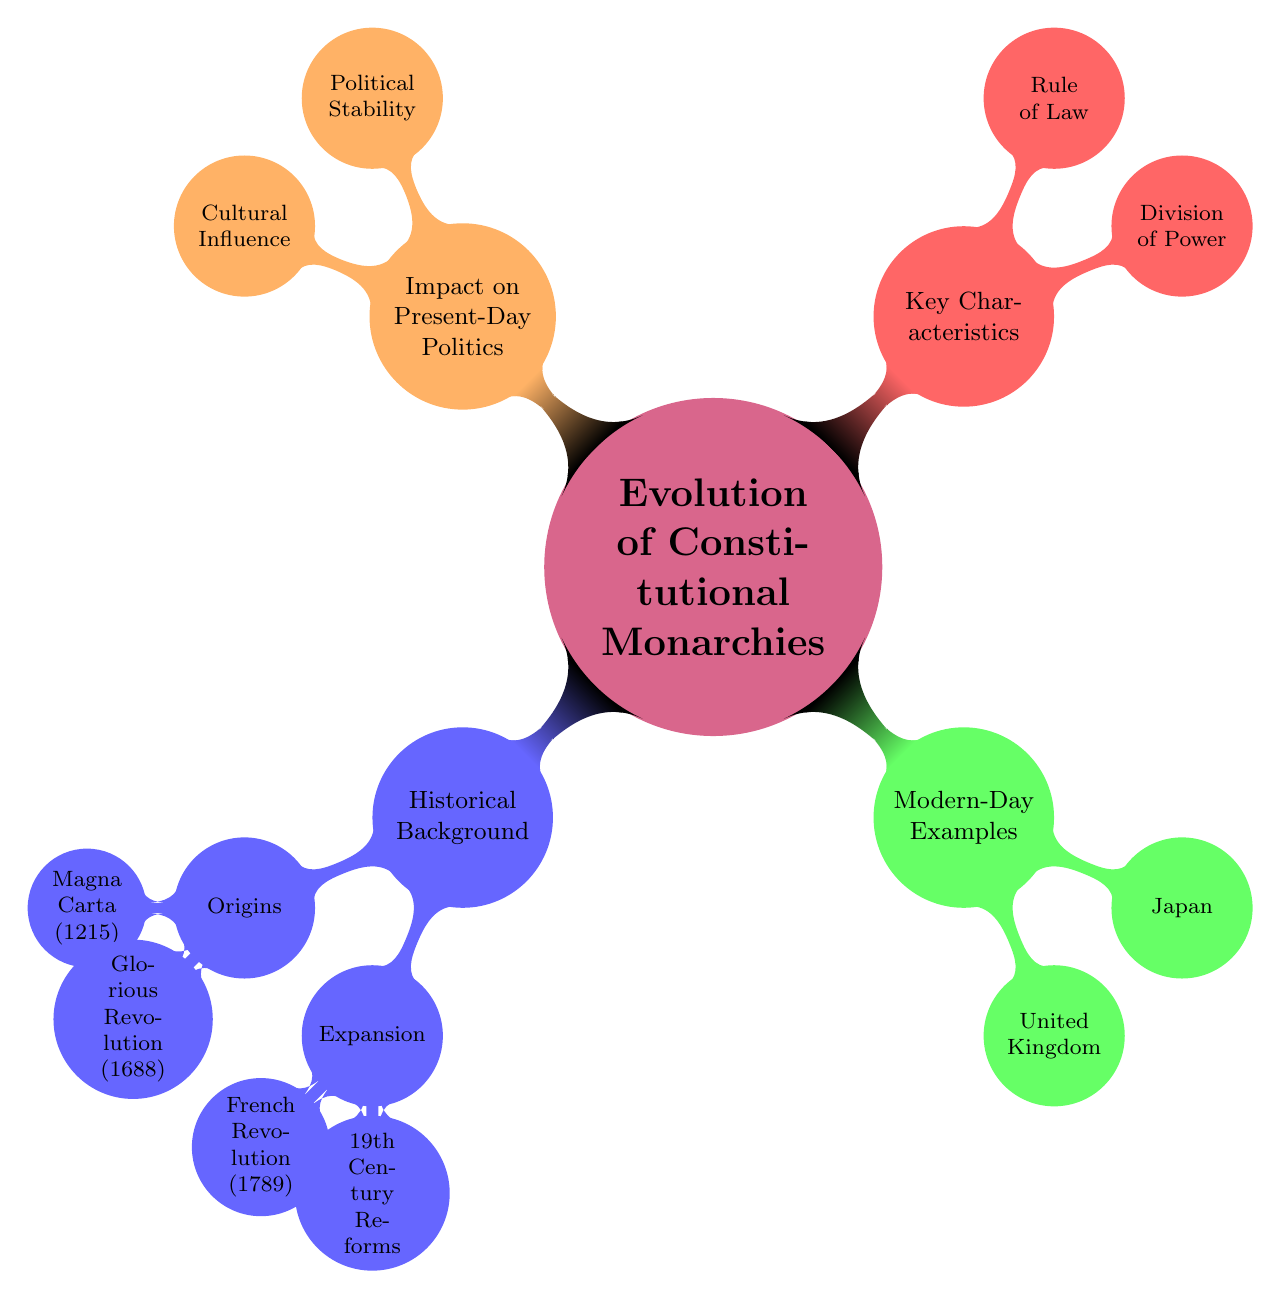What is the main topic of the mind map? The central node in the diagram states that the main topic is "Evolution of Constitutional Monarchies and Their Modern-Day Relevance." Thus, by looking at the main node, we can directly identify the main topic.
Answer: Evolution of Constitutional Monarchies and Their Modern-Day Relevance How many nodes are under "Historical Background"? The "Historical Background" branch contains two main child nodes: "Origins" and "Expansion." Thus, the total number of nodes under it is two.
Answer: 2 What significant event does "Magnacarta (1215)" relate to? From the "Origins" sub-branch under "Historical Background," "Magna Carta (1215)" is listed as an early step towards limiting monarchic power in England. Hence, it is related to that significant event.
Answer: Limiting monarchic power Which two examples of modern-day constitutional monarchies are presented? Under the "Modern-Day Examples" branch, the two specific examples provided are the "United Kingdom" and "Japan." Therefore, we can identify these as the modern-day constitutional monarchies referenced.
Answer: United Kingdom, Japan How does the "United Kingdom" exemplify a constitutional monarchy? The node under "Modern-Day Examples" indicates that the "United Kingdom" is described as a model of a well-functioning constitutional monarchy with a parliamentary system. This illustrates its adherence to the constitutional monarchy framework.
Answer: Well-functioning with a parliamentary system What impact do constitutional monarchies have on political stability? The "Impact on Present-Day Politics" section cites "Political Stability" as a result of constitutional monarchies, indicating that these systems provide continuity and stability in governance. Thus, the answer reflects this benefit.
Answer: Provides continuity and stability What is one key characteristic of constitutional monarchies according to the diagram? In the "Key Characteristics" section, "Division of Power" is highlighted. This suggests that a key feature of constitutional monarchies is the division between ceremonial and political functions.
Answer: Division of Power How did the "French Revolution (1789)" affect monarchies in Europe? The "Expansion" sub-branch under "Historical Background" states that the "French Revolution (1789)" led to the decline of absolute monarchies in Europe, indicating its significant impact.
Answer: Decline of absolute monarchies What role does the "Rule of Law" play in constitutional monarchies? The "Rule of Law" node under "Key Characteristics" describes that law is above the monarch, ensuring checks and balances. This indicates that the rule of law is crucial for maintaining a balanced governance structure in constitutional monarchies.
Answer: Ensures checks and balances 